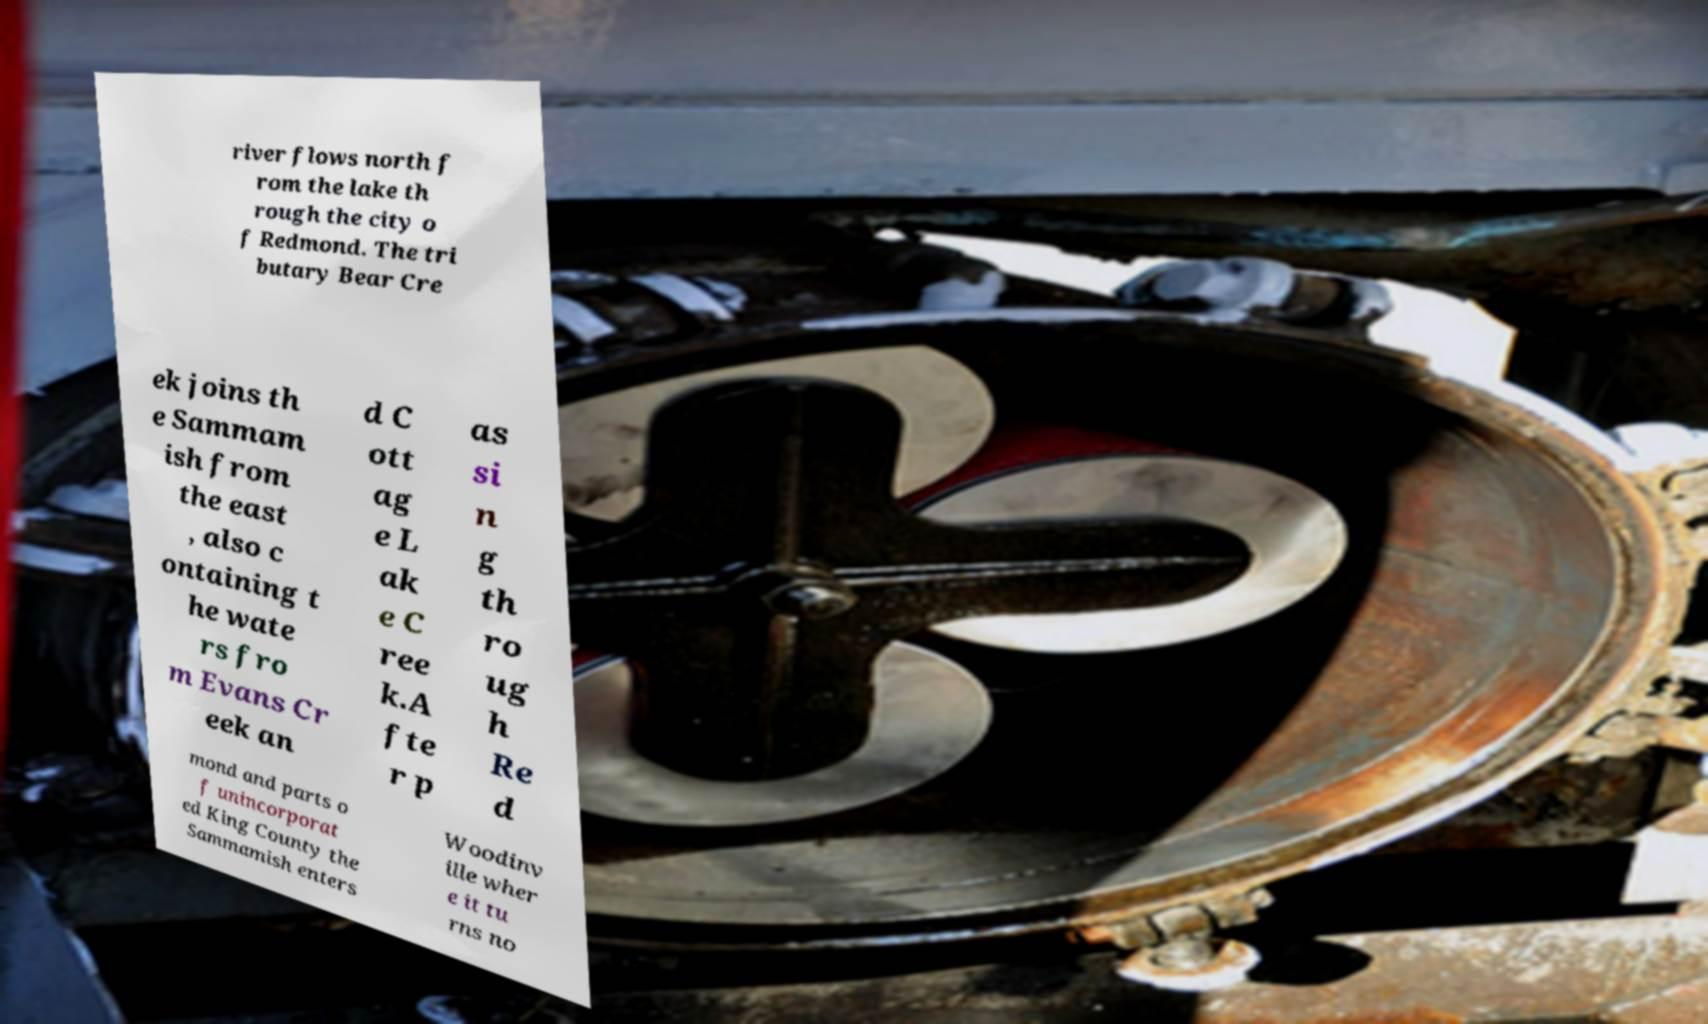Could you extract and type out the text from this image? river flows north f rom the lake th rough the city o f Redmond. The tri butary Bear Cre ek joins th e Sammam ish from the east , also c ontaining t he wate rs fro m Evans Cr eek an d C ott ag e L ak e C ree k.A fte r p as si n g th ro ug h Re d mond and parts o f unincorporat ed King County the Sammamish enters Woodinv ille wher e it tu rns no 